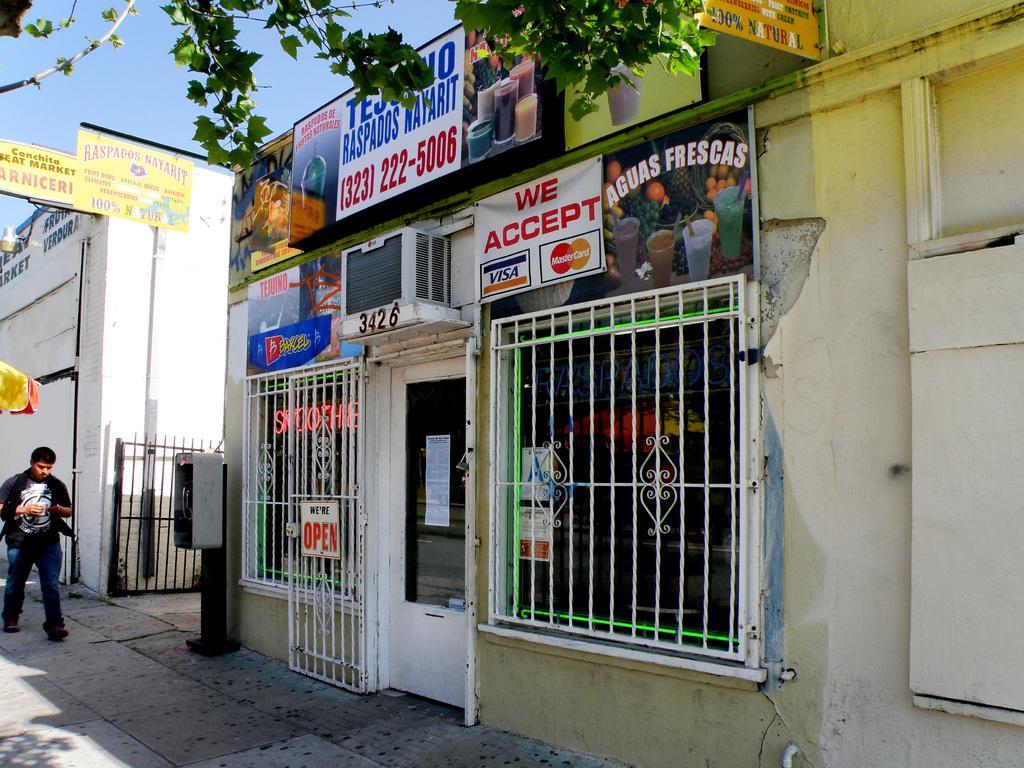Could you give a brief overview of what you see in this image? On the left side of the side of the image we can see a person is walking and some posters. In the middle of the image we can see a shop, air conditioner, leaves and a board. On the right side of the image we can see a wall. 